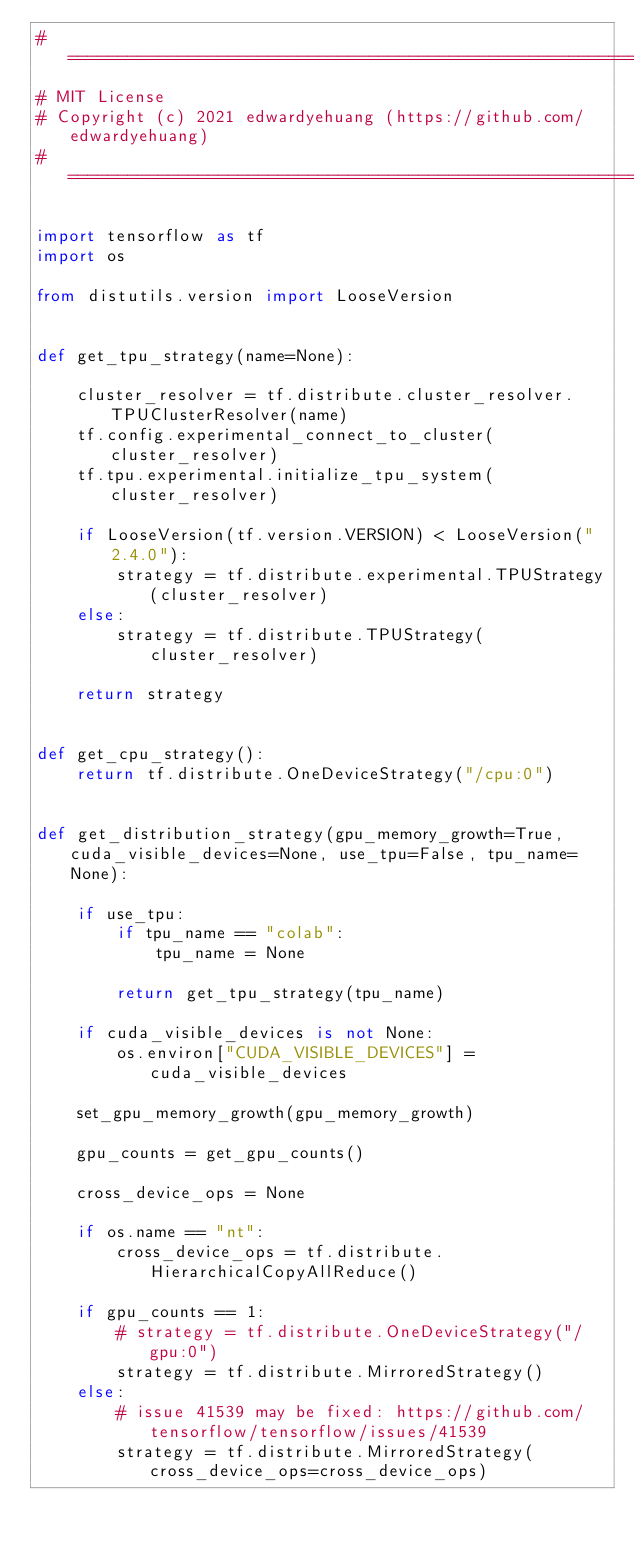Convert code to text. <code><loc_0><loc_0><loc_500><loc_500><_Python_># ================================================================
# MIT License
# Copyright (c) 2021 edwardyehuang (https://github.com/edwardyehuang)
# ================================================================

import tensorflow as tf
import os

from distutils.version import LooseVersion


def get_tpu_strategy(name=None):

    cluster_resolver = tf.distribute.cluster_resolver.TPUClusterResolver(name)
    tf.config.experimental_connect_to_cluster(cluster_resolver)
    tf.tpu.experimental.initialize_tpu_system(cluster_resolver)

    if LooseVersion(tf.version.VERSION) < LooseVersion("2.4.0"):
        strategy = tf.distribute.experimental.TPUStrategy(cluster_resolver)
    else:
        strategy = tf.distribute.TPUStrategy(cluster_resolver)

    return strategy


def get_cpu_strategy():
    return tf.distribute.OneDeviceStrategy("/cpu:0")


def get_distribution_strategy(gpu_memory_growth=True, cuda_visible_devices=None, use_tpu=False, tpu_name=None):

    if use_tpu:
        if tpu_name == "colab":
            tpu_name = None

        return get_tpu_strategy(tpu_name)

    if cuda_visible_devices is not None:
        os.environ["CUDA_VISIBLE_DEVICES"] = cuda_visible_devices

    set_gpu_memory_growth(gpu_memory_growth)

    gpu_counts = get_gpu_counts()

    cross_device_ops = None

    if os.name == "nt":
        cross_device_ops = tf.distribute.HierarchicalCopyAllReduce()

    if gpu_counts == 1:
        # strategy = tf.distribute.OneDeviceStrategy("/gpu:0")
        strategy = tf.distribute.MirroredStrategy()
    else:
        # issue 41539 may be fixed: https://github.com/tensorflow/tensorflow/issues/41539
        strategy = tf.distribute.MirroredStrategy(cross_device_ops=cross_device_ops)</code> 